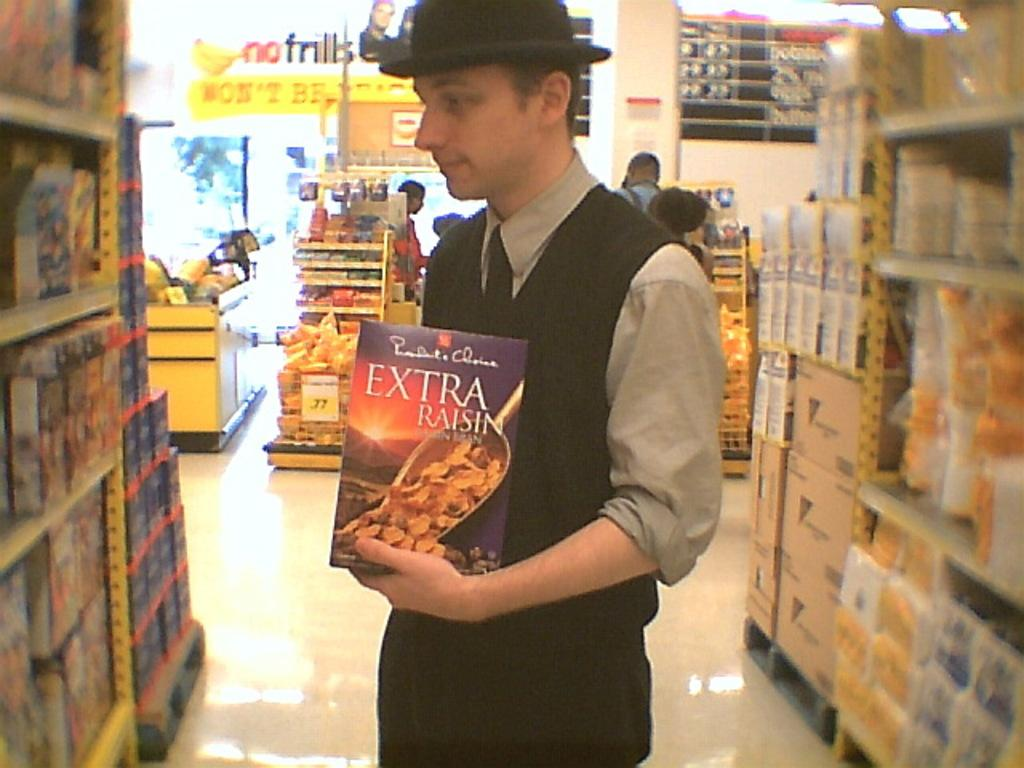Who is present in the image? There is a man in the image. Where is the man located? The man is in a supermarket. What is the man holding in his hand? The man is holding a box in his hand. What is the man wearing on his head? The man is wearing a black color hat. What type of clothing is the man wearing around his neck? The man is wearing a tie. What color are the trousers the man is wearing? The man is wearing black color trousers. How many horses are visible in the image? There are no horses present in the image. What type of land can be seen in the image? The image does not depict any land; it is set in a supermarket. 